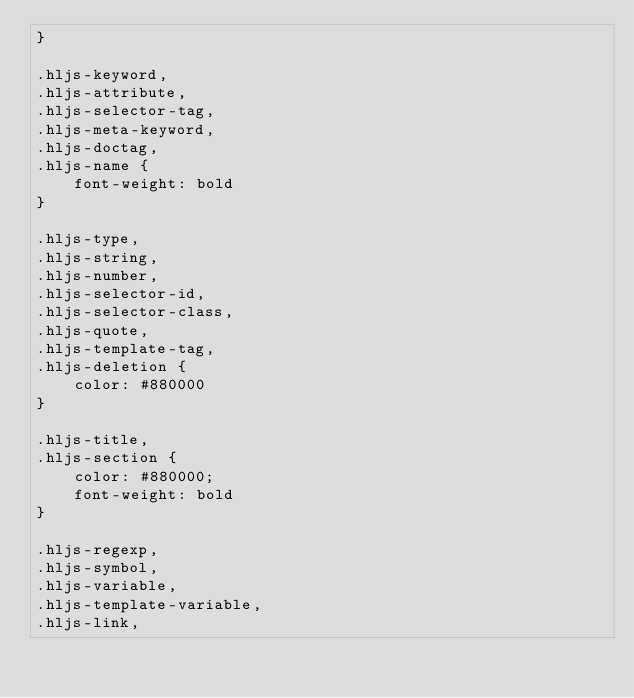Convert code to text. <code><loc_0><loc_0><loc_500><loc_500><_CSS_>}

.hljs-keyword,
.hljs-attribute,
.hljs-selector-tag,
.hljs-meta-keyword,
.hljs-doctag,
.hljs-name {
    font-weight: bold
}

.hljs-type,
.hljs-string,
.hljs-number,
.hljs-selector-id,
.hljs-selector-class,
.hljs-quote,
.hljs-template-tag,
.hljs-deletion {
    color: #880000
}

.hljs-title,
.hljs-section {
    color: #880000;
    font-weight: bold
}

.hljs-regexp,
.hljs-symbol,
.hljs-variable,
.hljs-template-variable,
.hljs-link,</code> 